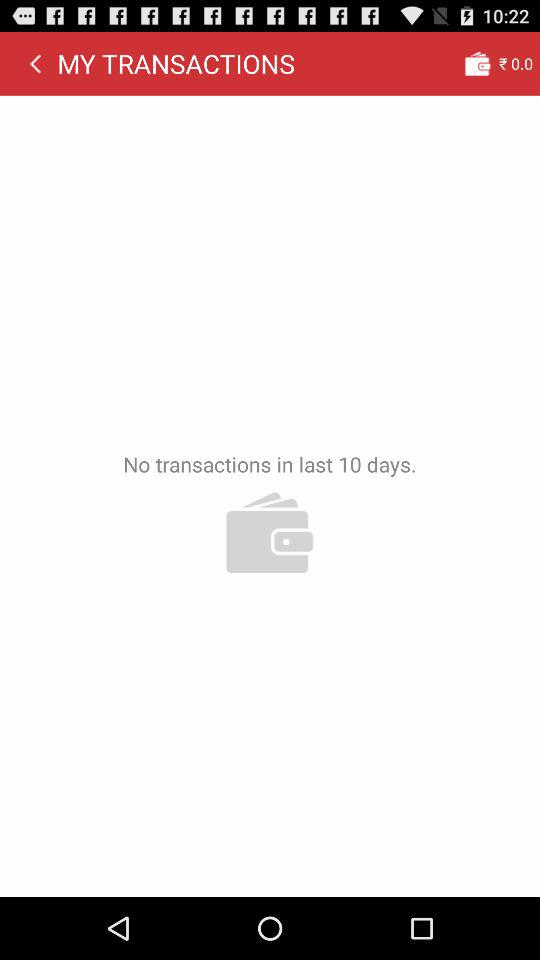How much money do I have in my wallet?
Answer the question using a single word or phrase. ₹0.0 